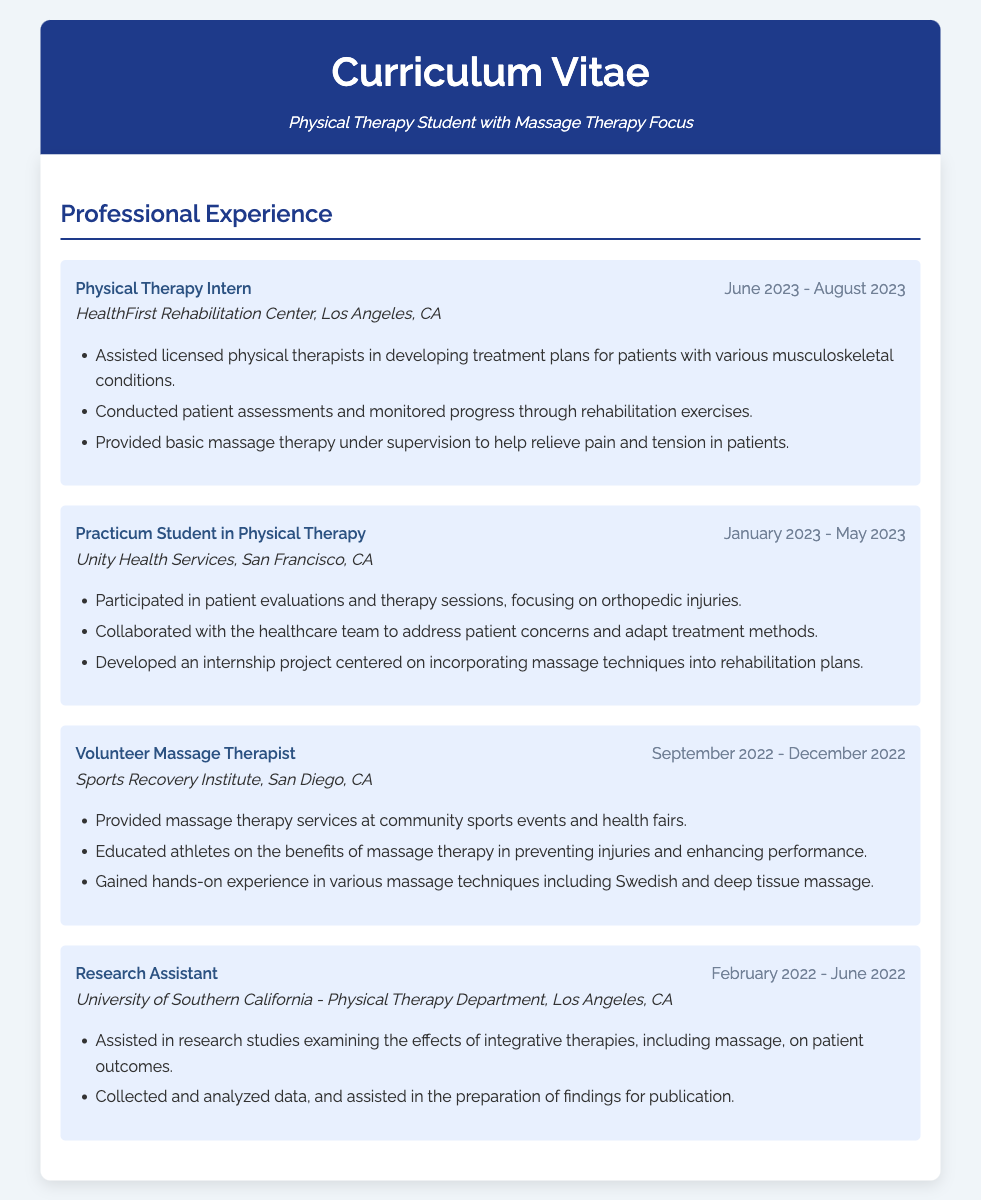What was the position held at HealthFirst Rehabilitation Center? The position held was "Physical Therapy Intern" from June 2023 to August 2023.
Answer: Physical Therapy Intern What was the primary focus of the practicum at Unity Health Services? The practicum focused on orthopedic injuries during the period from January 2023 to May 2023.
Answer: Orthopedic injuries During which months did the volunteer experience at Sports Recovery Institute take place? The volunteer experience occurred from September 2022 to December 2022.
Answer: September 2022 - December 2022 What type of massage techniques were gained during the volunteer position? The volunteer position involved various massage techniques including Swedish and deep tissue massage.
Answer: Swedish and deep tissue massage What was the role of the individual at the University of Southern California? The role was "Research Assistant" from February 2022 to June 2022.
Answer: Research Assistant What was a key project developed during the practicum? The key project focused on incorporating massage techniques into rehabilitation plans.
Answer: Incorporating massage techniques into rehabilitation plans What organization was involved in providing massage therapy at community sports events? The organization that provided massage therapy was the Sports Recovery Institute.
Answer: Sports Recovery Institute What supervision level was provided for massage therapy at HealthFirst Rehabilitation Center? The supervision level for massage therapy was under licensed physical therapists.
Answer: Under supervision 